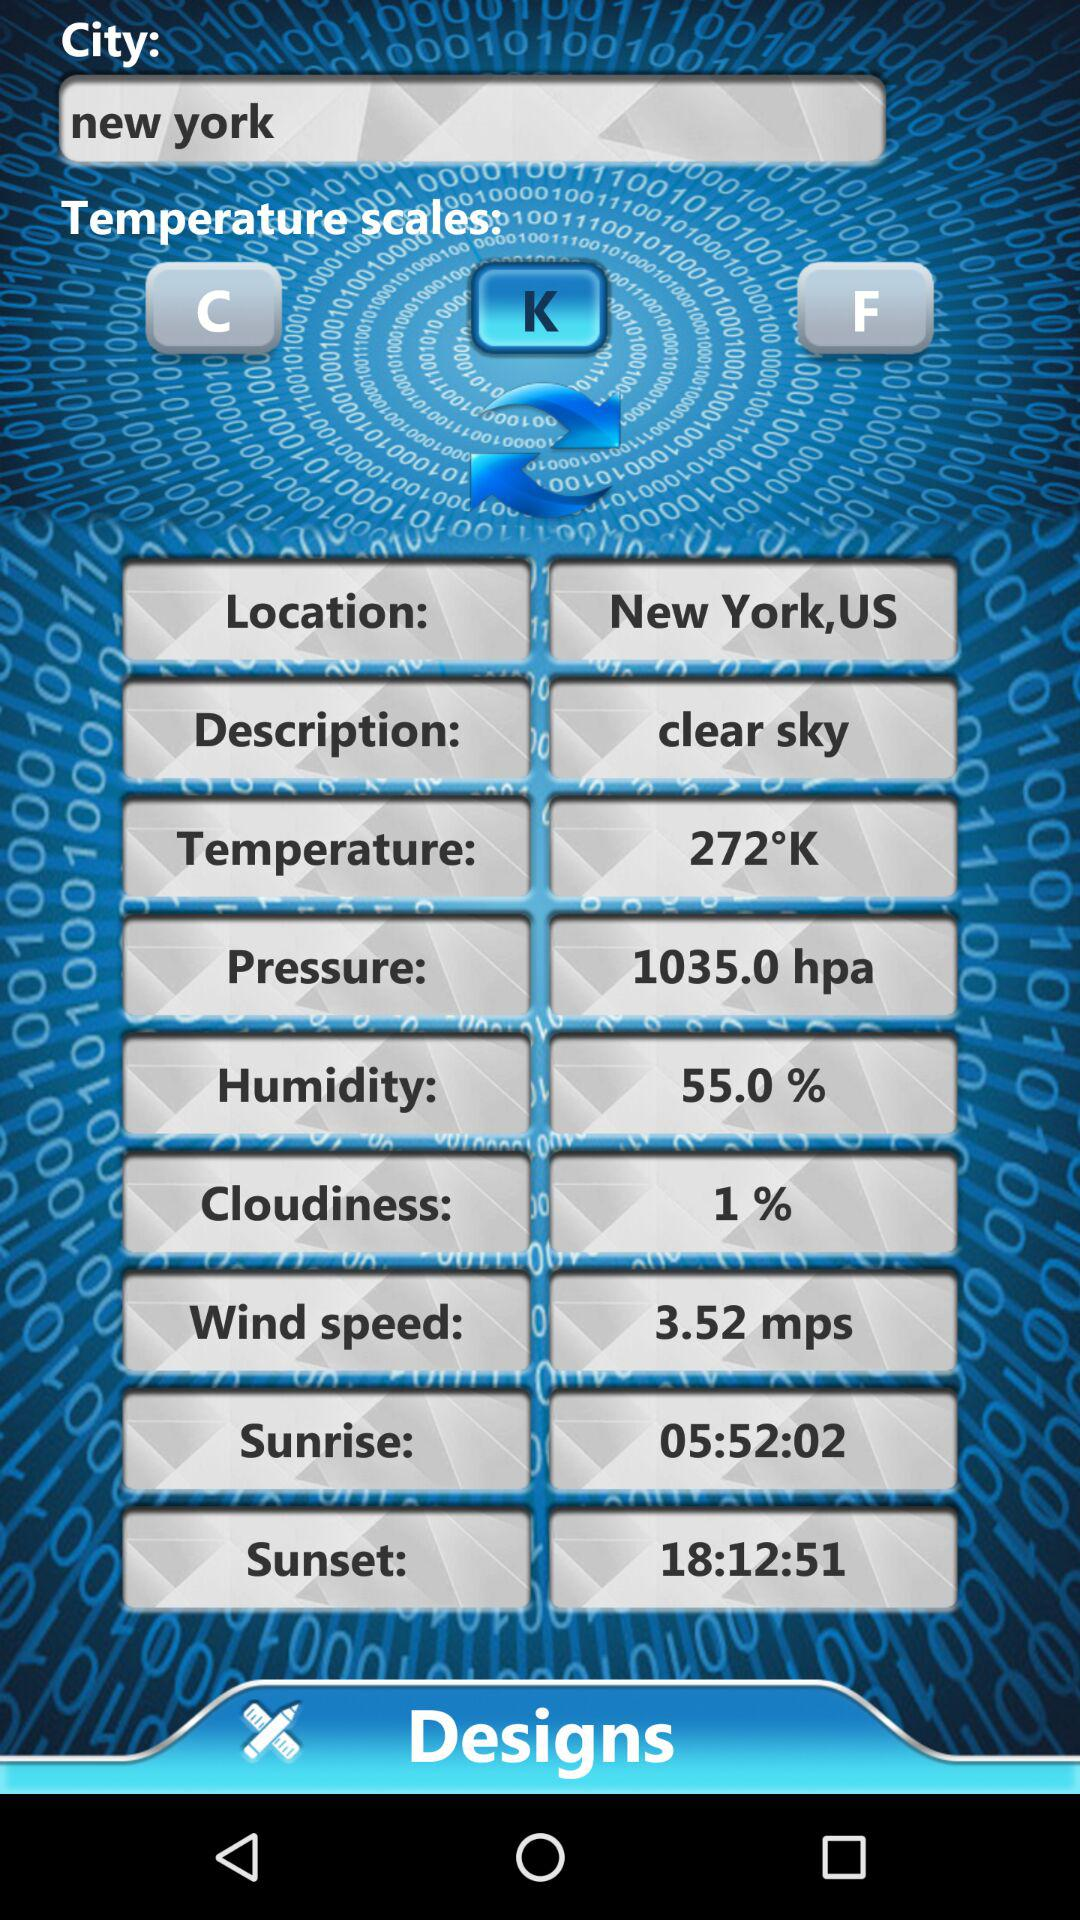What is the location? The location is New York,US. 